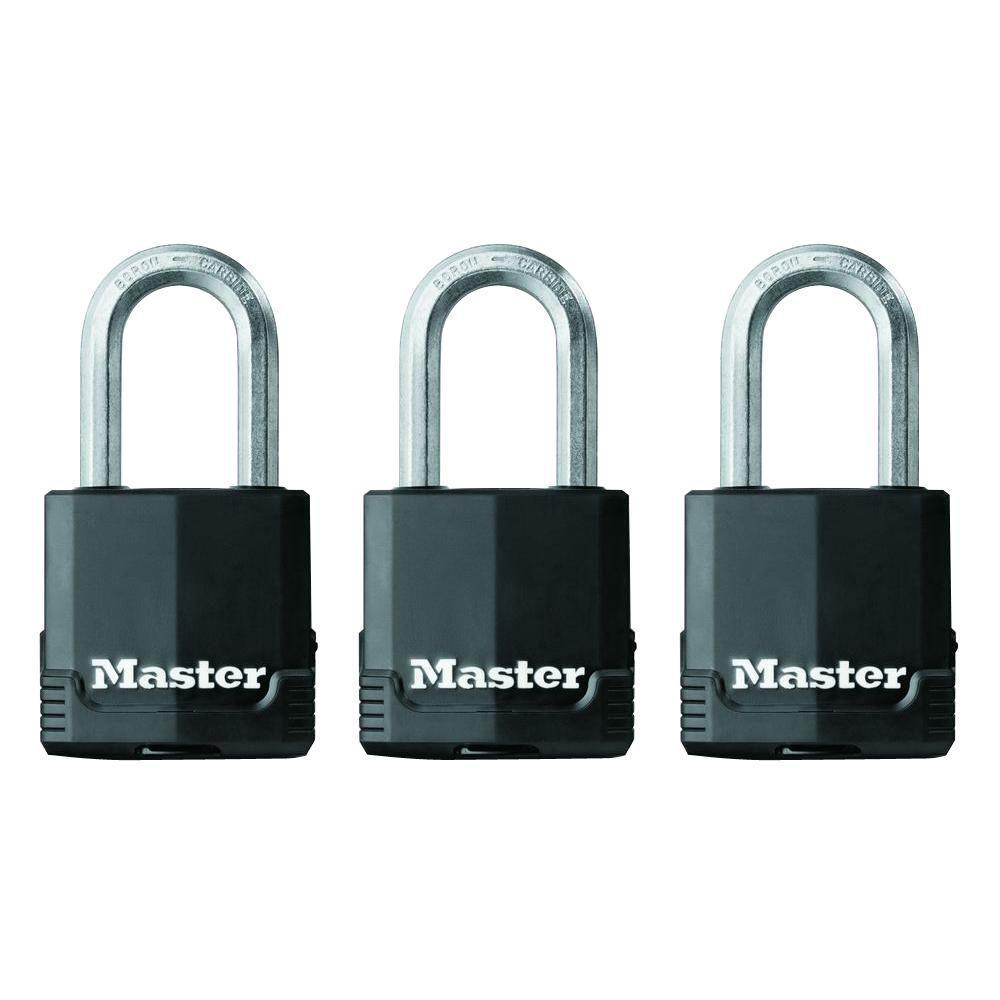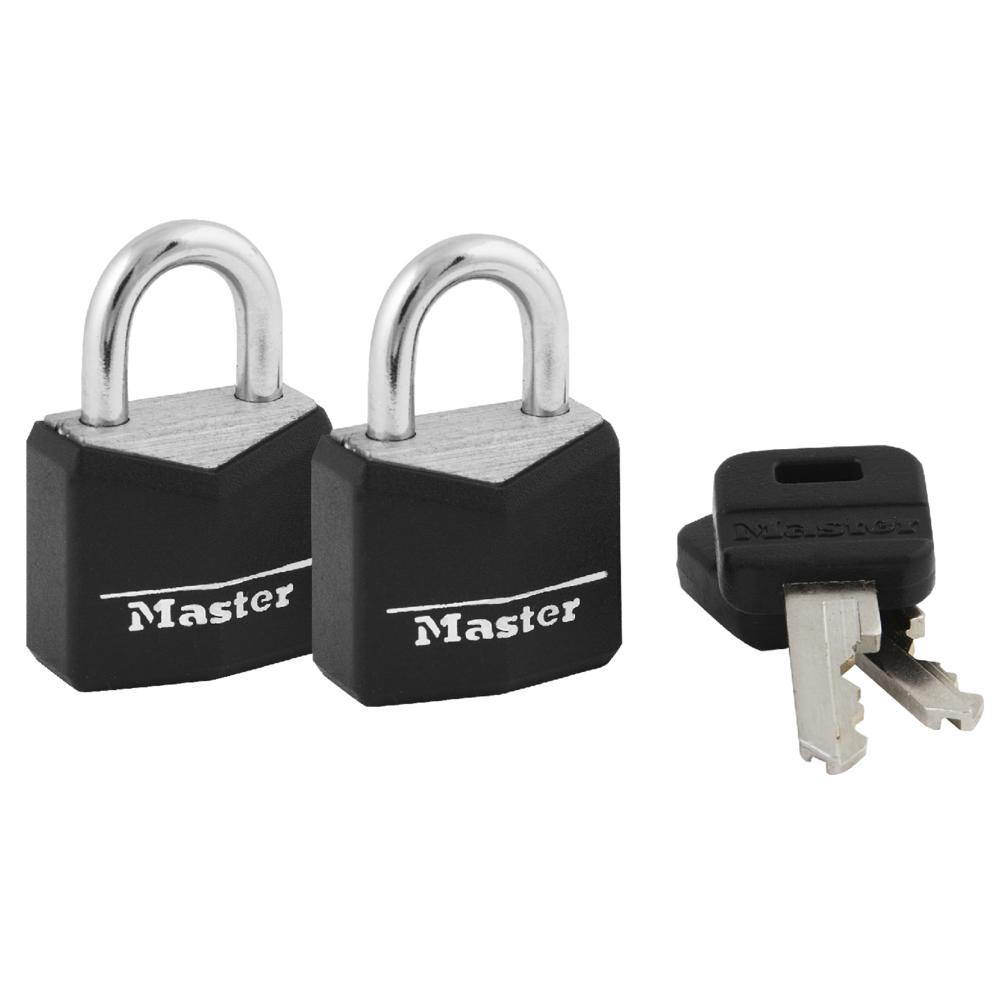The first image is the image on the left, the second image is the image on the right. For the images shown, is this caption "An image shows a stack of two black-topped keys next to two overlapping upright black padlocks." true? Answer yes or no. Yes. The first image is the image on the left, the second image is the image on the right. Given the left and right images, does the statement "There are more locks in the image on the right than in the image on the left." hold true? Answer yes or no. No. 